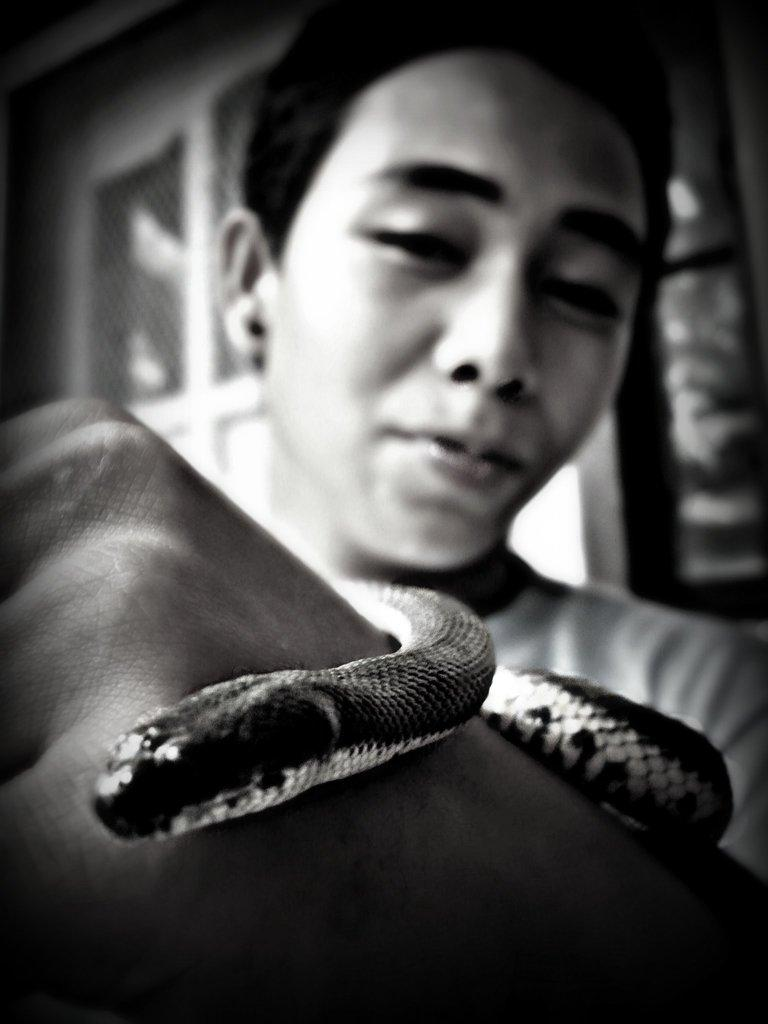What is the main subject of the image? The main subject of the image is a man. What is the man doing in the image? The man is holding a snake on his hand. What type of machine can be seen in the background of the image? There is no machine present in the image; it only features a man holding a snake. How many brothers does the man have in the image? There is no information about the man's brothers in the image. 